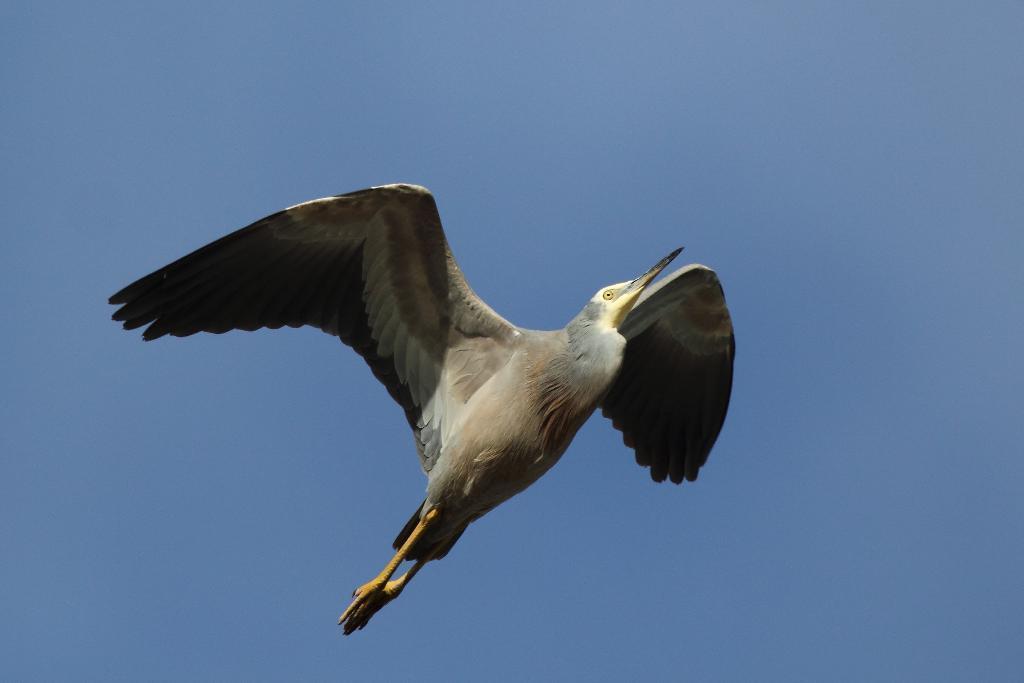How would you summarize this image in a sentence or two? In the image there is a bird flying in the sky. 